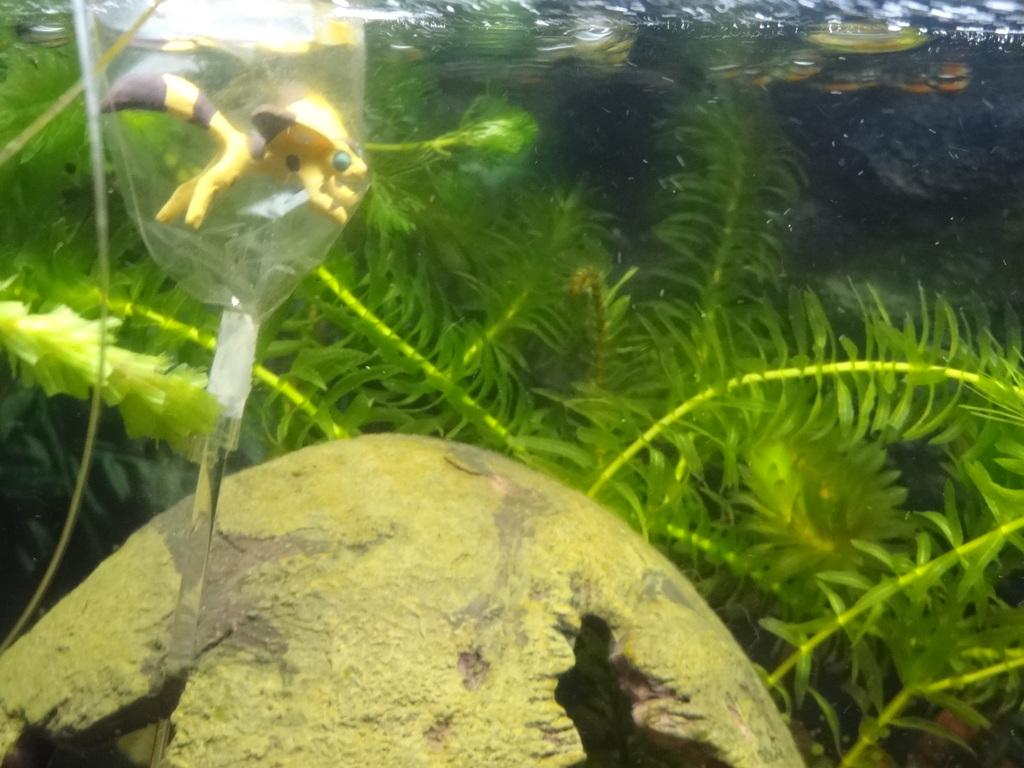What is the setting of the image? The image is underwater. What can be seen in the image besides the underwater environment? There is an object and plants visible in the image. What type of jeans is the animal wearing in the image? There is no animal or jeans present in the image; it is an underwater scene with an object and plants. 